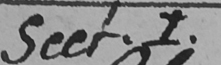Please provide the text content of this handwritten line. Sect.1 . 